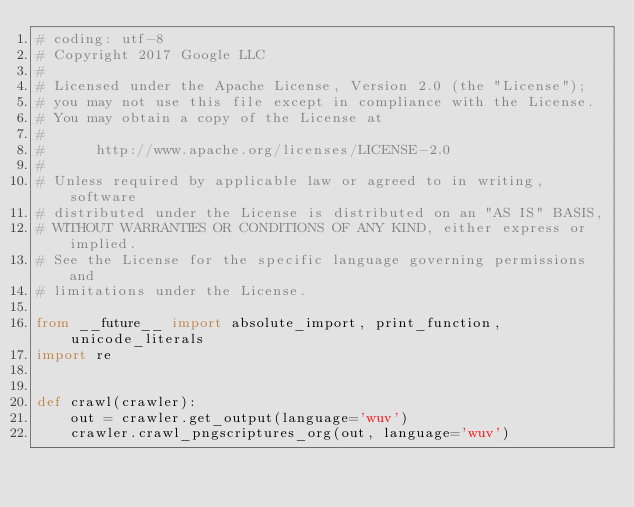<code> <loc_0><loc_0><loc_500><loc_500><_Python_># coding: utf-8
# Copyright 2017 Google LLC
#
# Licensed under the Apache License, Version 2.0 (the "License");
# you may not use this file except in compliance with the License.
# You may obtain a copy of the License at
#
#      http://www.apache.org/licenses/LICENSE-2.0
#
# Unless required by applicable law or agreed to in writing, software
# distributed under the License is distributed on an "AS IS" BASIS,
# WITHOUT WARRANTIES OR CONDITIONS OF ANY KIND, either express or implied.
# See the License for the specific language governing permissions and
# limitations under the License.

from __future__ import absolute_import, print_function, unicode_literals
import re


def crawl(crawler):
    out = crawler.get_output(language='wuv')
    crawler.crawl_pngscriptures_org(out, language='wuv')
</code> 